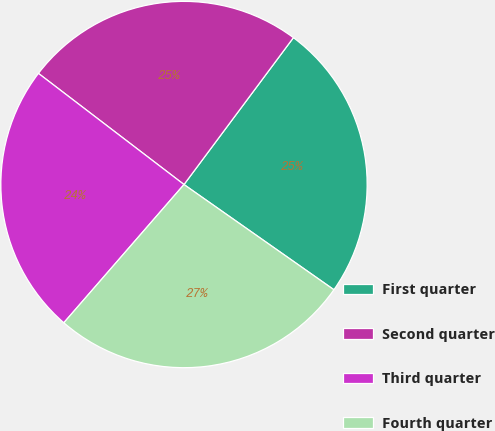<chart> <loc_0><loc_0><loc_500><loc_500><pie_chart><fcel>First quarter<fcel>Second quarter<fcel>Third quarter<fcel>Fourth quarter<nl><fcel>24.55%<fcel>24.81%<fcel>23.99%<fcel>26.65%<nl></chart> 